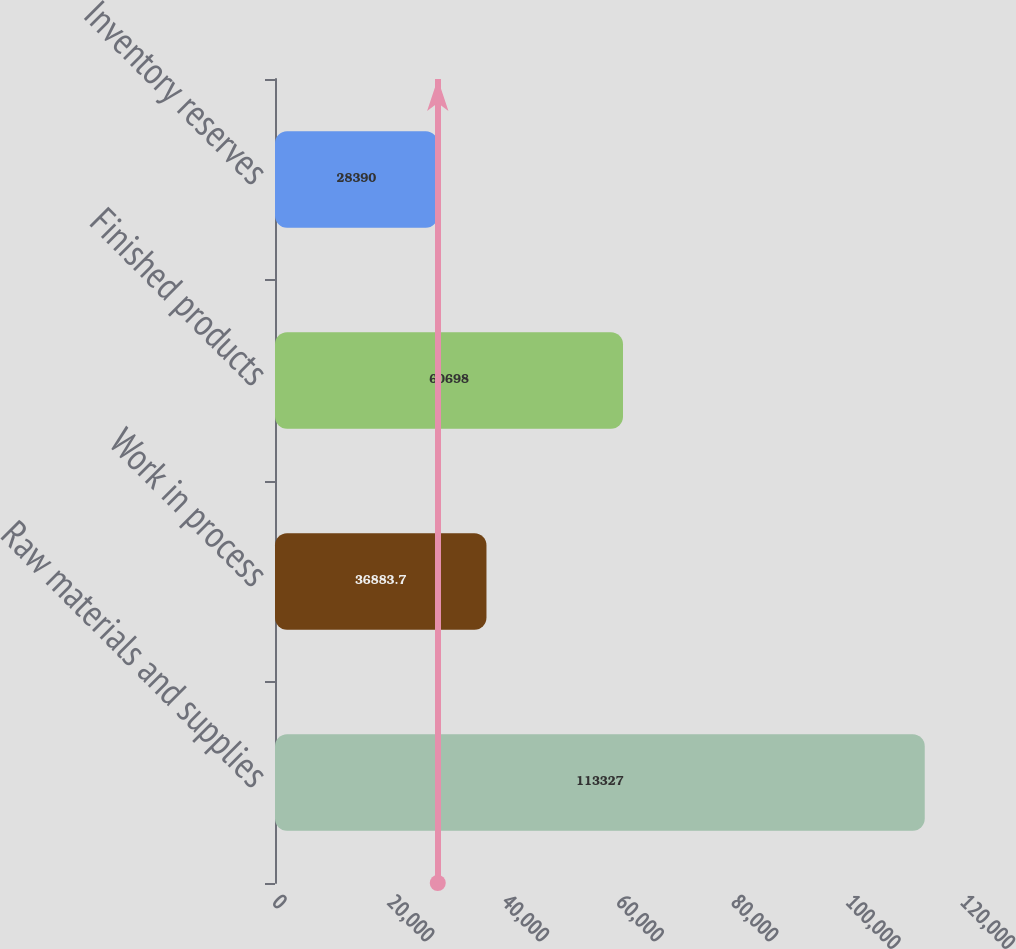Convert chart to OTSL. <chart><loc_0><loc_0><loc_500><loc_500><bar_chart><fcel>Raw materials and supplies<fcel>Work in process<fcel>Finished products<fcel>Inventory reserves<nl><fcel>113327<fcel>36883.7<fcel>60698<fcel>28390<nl></chart> 